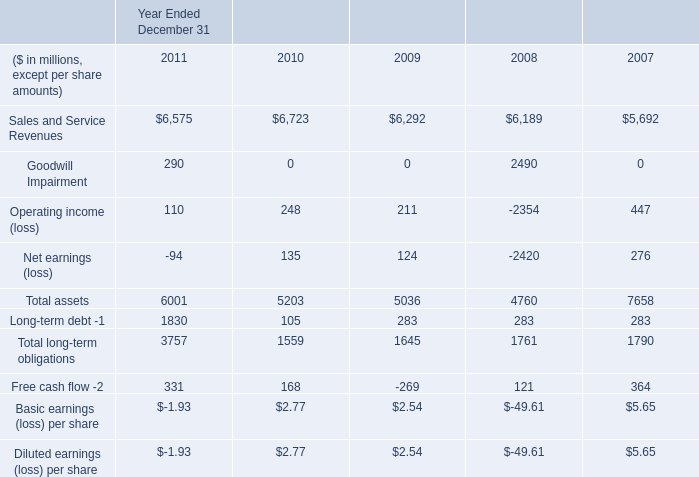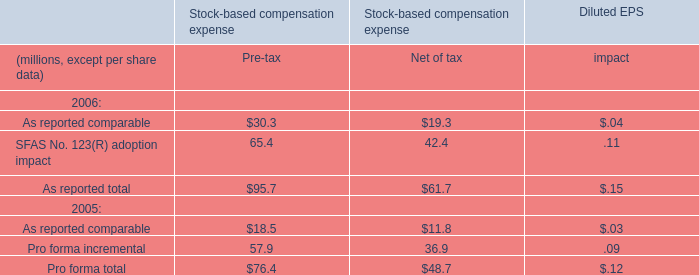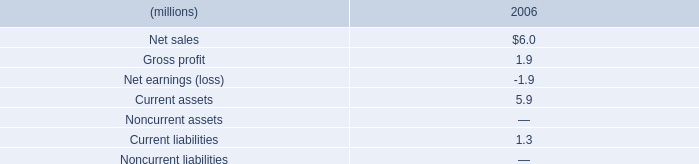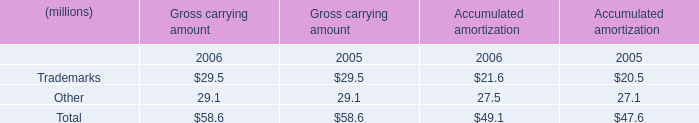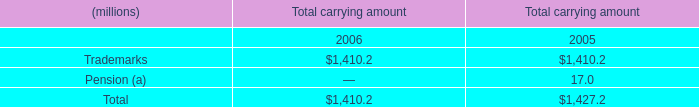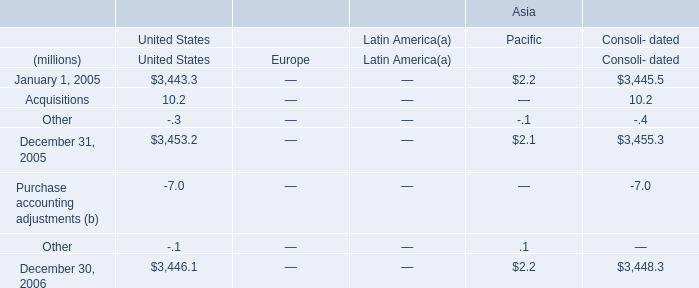Which year is the sum of Total carrying amount the most? 
Answer: 2005. 